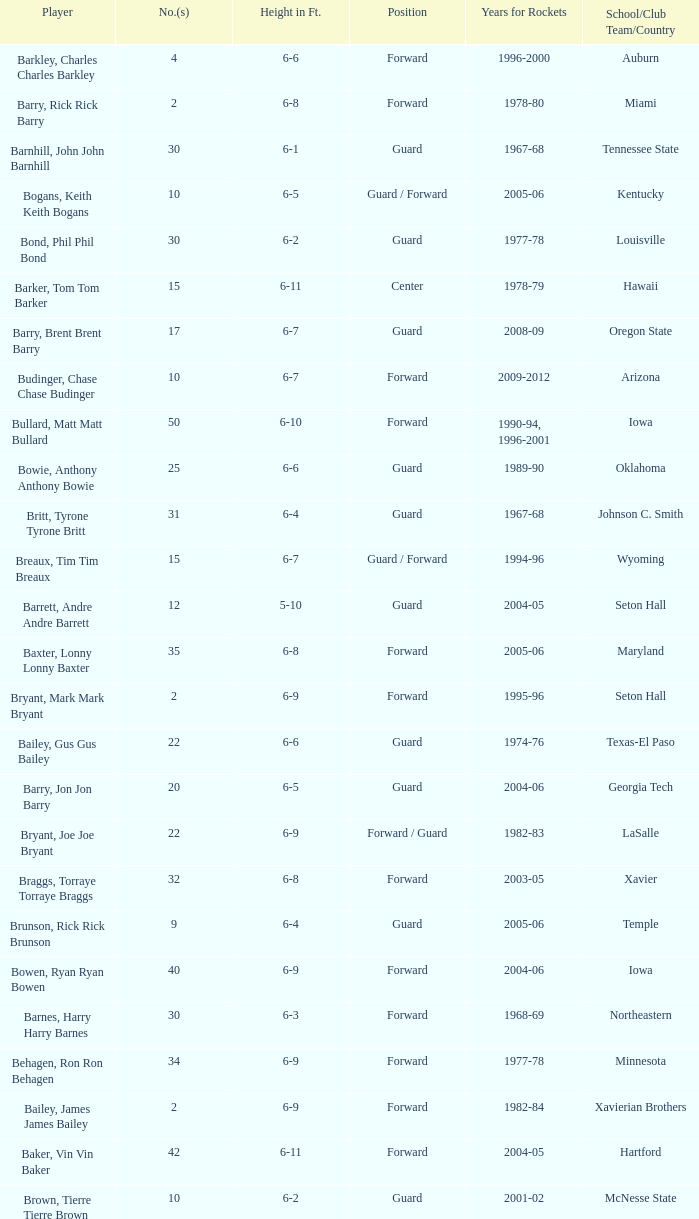What is the height of the player who attended Hartford? 6-11. 